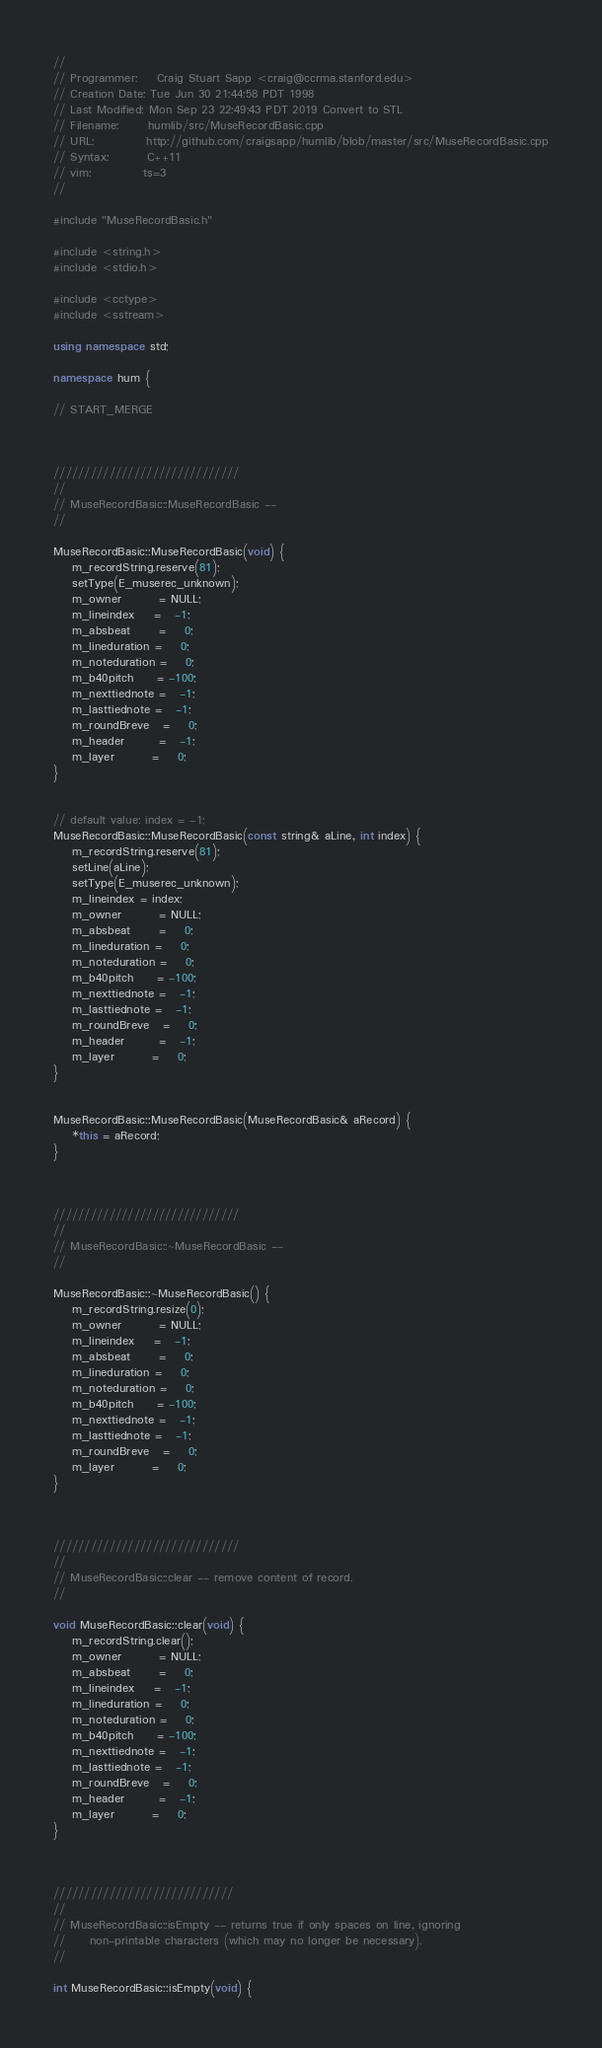Convert code to text. <code><loc_0><loc_0><loc_500><loc_500><_C++_>//
// Programmer:    Craig Stuart Sapp <craig@ccrma.stanford.edu>
// Creation Date: Tue Jun 30 21:44:58 PDT 1998
// Last Modified: Mon Sep 23 22:49:43 PDT 2019 Convert to STL
// Filename:      humlib/src/MuseRecordBasic.cpp
// URL:           http://github.com/craigsapp/humlib/blob/master/src/MuseRecordBasic.cpp
// Syntax:        C++11
// vim:           ts=3
//

#include "MuseRecordBasic.h"

#include <string.h>
#include <stdio.h>

#include <cctype>
#include <sstream>

using namespace std;

namespace hum {

// START_MERGE



//////////////////////////////
//
// MuseRecordBasic::MuseRecordBasic --
//

MuseRecordBasic::MuseRecordBasic(void) {
	m_recordString.reserve(81);
	setType(E_muserec_unknown);
	m_owner        = NULL;
	m_lineindex    =   -1;
	m_absbeat      =    0;
	m_lineduration =    0;
	m_noteduration =    0;
	m_b40pitch     = -100;
	m_nexttiednote =   -1;
	m_lasttiednote =   -1;
	m_roundBreve   =    0;
	m_header       =   -1;
	m_layer        =    0;
}


// default value: index = -1;
MuseRecordBasic::MuseRecordBasic(const string& aLine, int index) {
	m_recordString.reserve(81);
	setLine(aLine);
	setType(E_muserec_unknown);
	m_lineindex = index;
	m_owner        = NULL;
	m_absbeat      =    0;
	m_lineduration =    0;
	m_noteduration =    0;
	m_b40pitch     = -100;
	m_nexttiednote =   -1;
	m_lasttiednote =   -1;
	m_roundBreve   =    0;
	m_header       =   -1;
	m_layer        =    0;
}


MuseRecordBasic::MuseRecordBasic(MuseRecordBasic& aRecord) {
	*this = aRecord;
}



//////////////////////////////
//
// MuseRecordBasic::~MuseRecordBasic --
//

MuseRecordBasic::~MuseRecordBasic() {
	m_recordString.resize(0);
	m_owner        = NULL;
	m_lineindex    =   -1;
	m_absbeat      =    0;
	m_lineduration =    0;
	m_noteduration =    0;
	m_b40pitch     = -100;
	m_nexttiednote =   -1;
	m_lasttiednote =   -1;
	m_roundBreve   =    0;
	m_layer        =    0;
}



//////////////////////////////
//
// MuseRecordBasic::clear -- remove content of record.
//

void MuseRecordBasic::clear(void) {
	m_recordString.clear();
	m_owner        = NULL;
	m_absbeat      =    0;
	m_lineindex    =   -1;
	m_lineduration =    0;
	m_noteduration =    0;
	m_b40pitch     = -100;
	m_nexttiednote =   -1;
	m_lasttiednote =   -1;
	m_roundBreve   =    0;
	m_header       =   -1;
	m_layer        =    0;
}



/////////////////////////////
//
// MuseRecordBasic::isEmpty -- returns true if only spaces on line, ignoring
//     non-printable characters (which may no longer be necessary).
//

int MuseRecordBasic::isEmpty(void) {</code> 